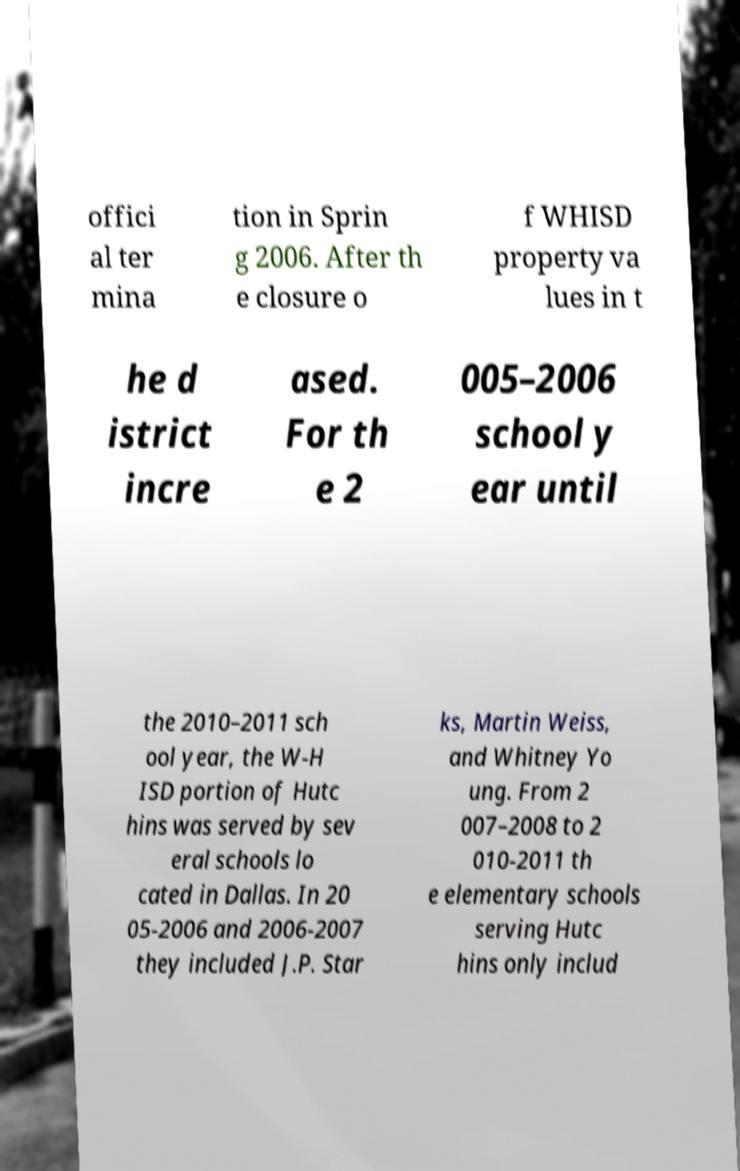Could you assist in decoding the text presented in this image and type it out clearly? offici al ter mina tion in Sprin g 2006. After th e closure o f WHISD property va lues in t he d istrict incre ased. For th e 2 005–2006 school y ear until the 2010–2011 sch ool year, the W-H ISD portion of Hutc hins was served by sev eral schools lo cated in Dallas. In 20 05-2006 and 2006-2007 they included J.P. Star ks, Martin Weiss, and Whitney Yo ung. From 2 007–2008 to 2 010-2011 th e elementary schools serving Hutc hins only includ 